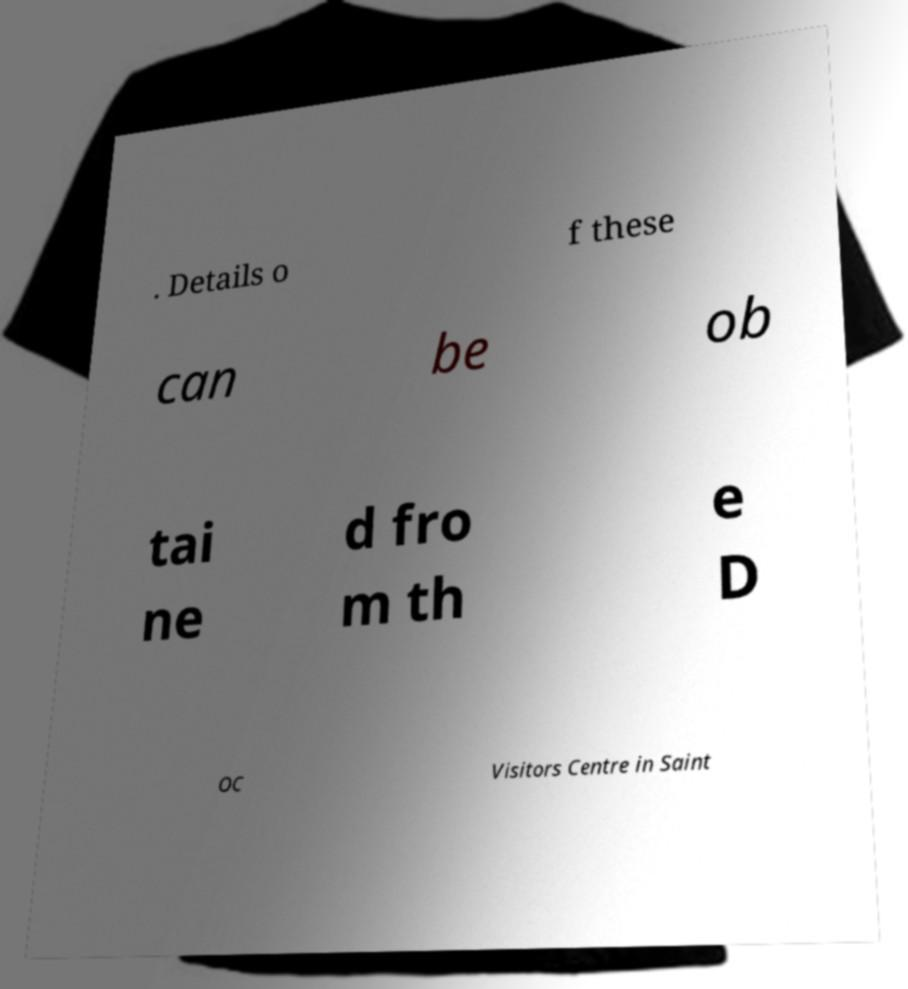What messages or text are displayed in this image? I need them in a readable, typed format. . Details o f these can be ob tai ne d fro m th e D OC Visitors Centre in Saint 